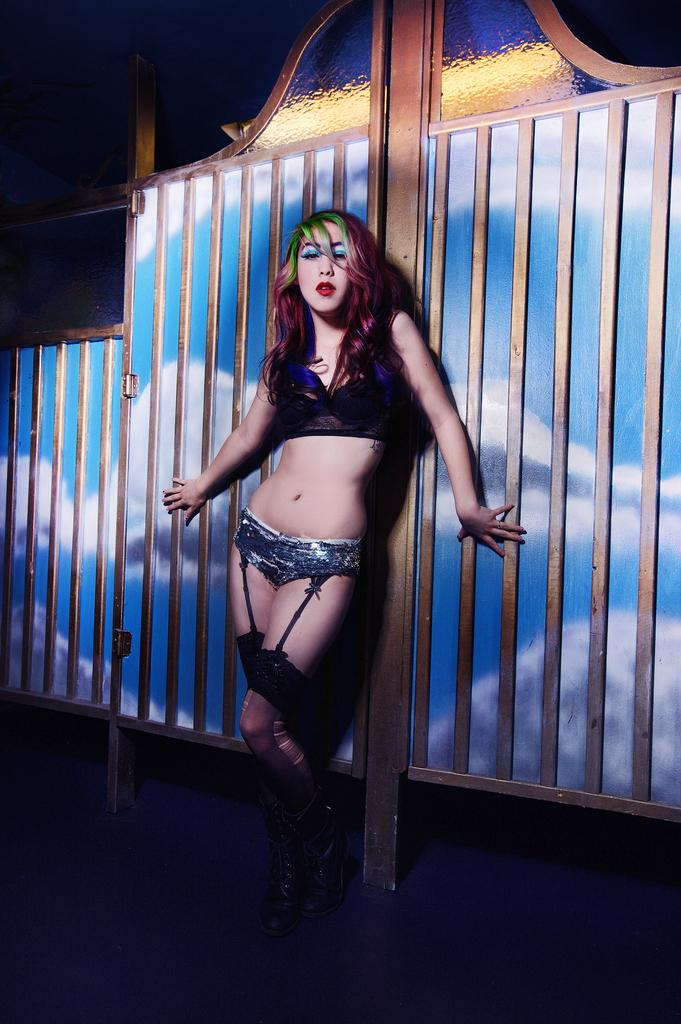What is the main subject of the image? The main subject of the image is a woman. What is the woman wearing in the image? The woman is wearing a bikini. What is the woman doing in the image? The woman is standing and leaning on fencing. What is the color of the background in the image? The background of the image is dark in color. What type of straw is the woman using to build her home in the image? There is no straw or home-building activity present in the image. 